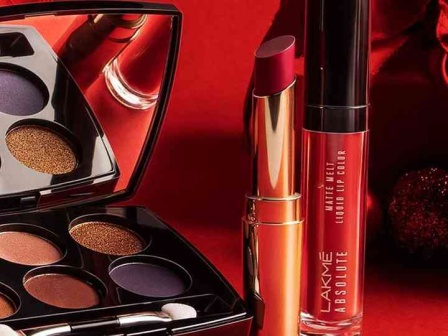Could you create a fictional story surrounding these makeup products as if they were part of a high-stakes spy mission? On the surface, the makeup products from Lakme appear ordinary—a shimmering eyeshadow palette, a vibrant lipstick, and a rich liquid lip color. Little did anyone know, these seemingly innocuous items were the secret tools of Agent Elle, the most glamorous spy the world had ever known. The eyeshadow palette did more than enhance beauty with its golden and purple shades; it held microscopic blueprints of a top-secret facility. The metallic orange lipstick doubled as a concealed communicator, capable of transmitting encrypted messages. The deep red liquid lip color contained a high-tech quick-drying adhesive, perfect for sealing envelopes, fixing gadgets, or even creating diversions. In a world teetering on the brink of chaos, it was Agent Elle’s mission to retrieve a stolen microchip hidden in a gala event. With her Lakme arsenal at hand, she navigated the ostentatious ball, blending in effortlessly. One stroke of the golden eyeshadow revealed a cipher on an antique mirror, leading her to a hidden vault. A quick word into her lipstick communicator summoned her team as she locked the vault door with a swipe of her liquid lip color. The day was saved, and the world saw nothing more than a glamorous woman reapplying her makeup. 